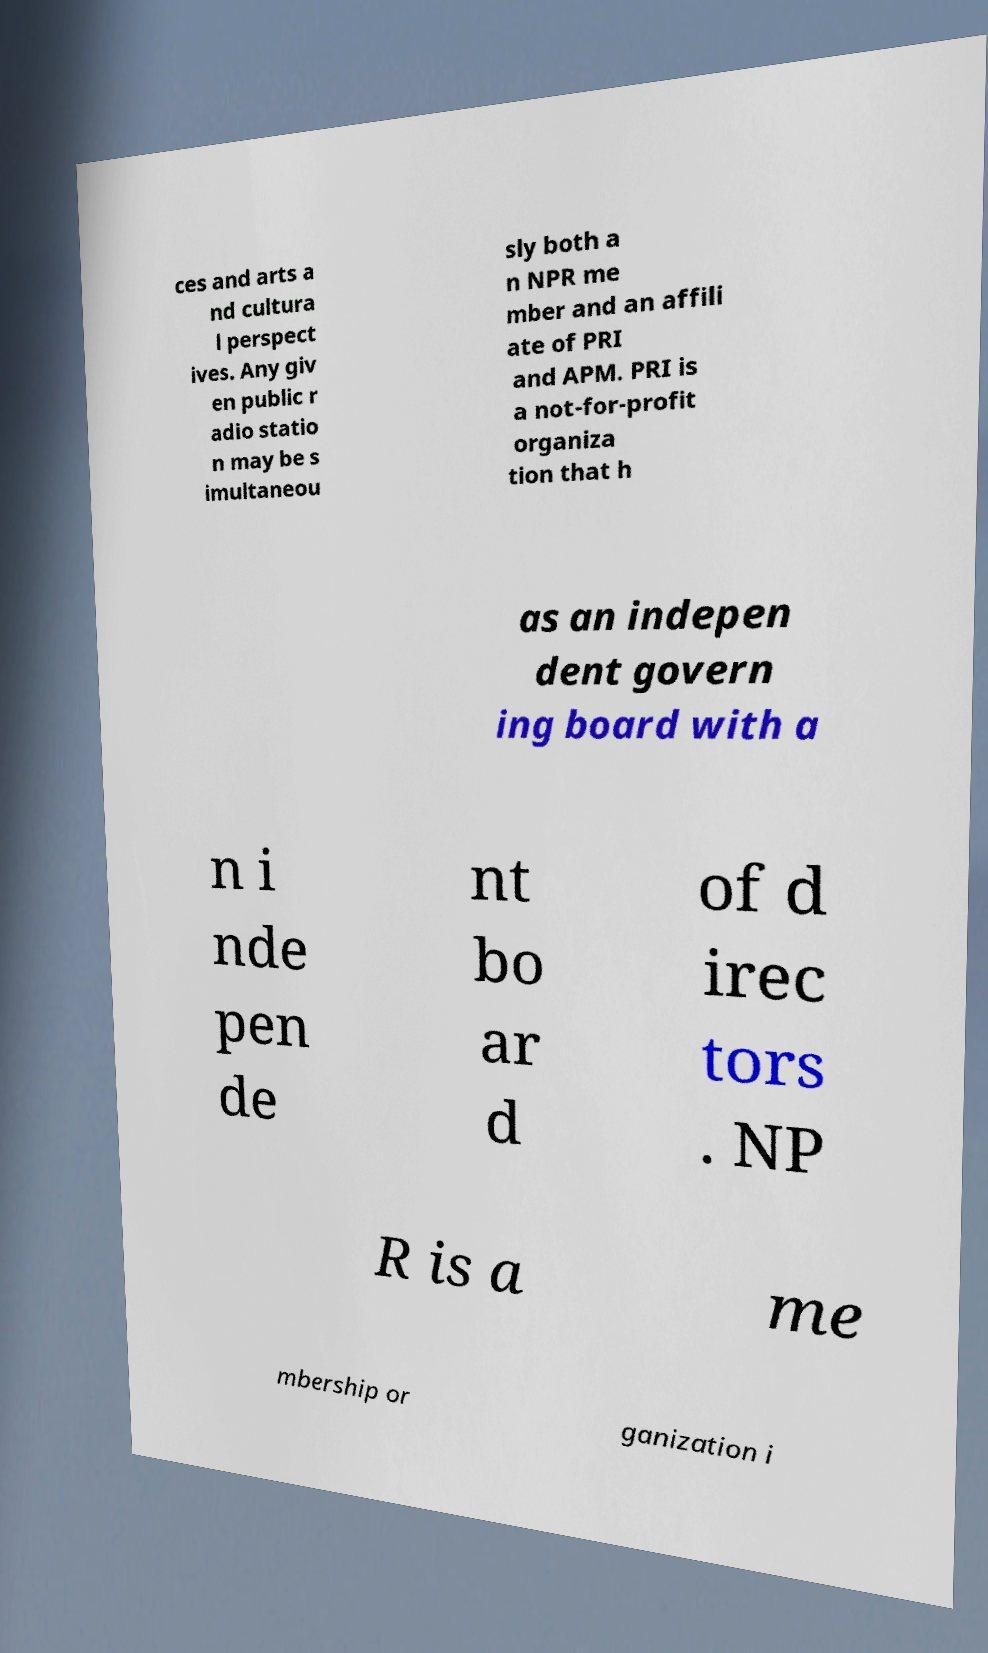There's text embedded in this image that I need extracted. Can you transcribe it verbatim? ces and arts a nd cultura l perspect ives. Any giv en public r adio statio n may be s imultaneou sly both a n NPR me mber and an affili ate of PRI and APM. PRI is a not-for-profit organiza tion that h as an indepen dent govern ing board with a n i nde pen de nt bo ar d of d irec tors . NP R is a me mbership or ganization i 